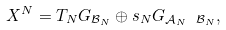<formula> <loc_0><loc_0><loc_500><loc_500>X ^ { N } = T _ { N } G _ { \mathcal { B } _ { N } } \oplus s _ { N } G _ { \mathcal { A } _ { N } \ \mathcal { B } _ { N } } ,</formula> 